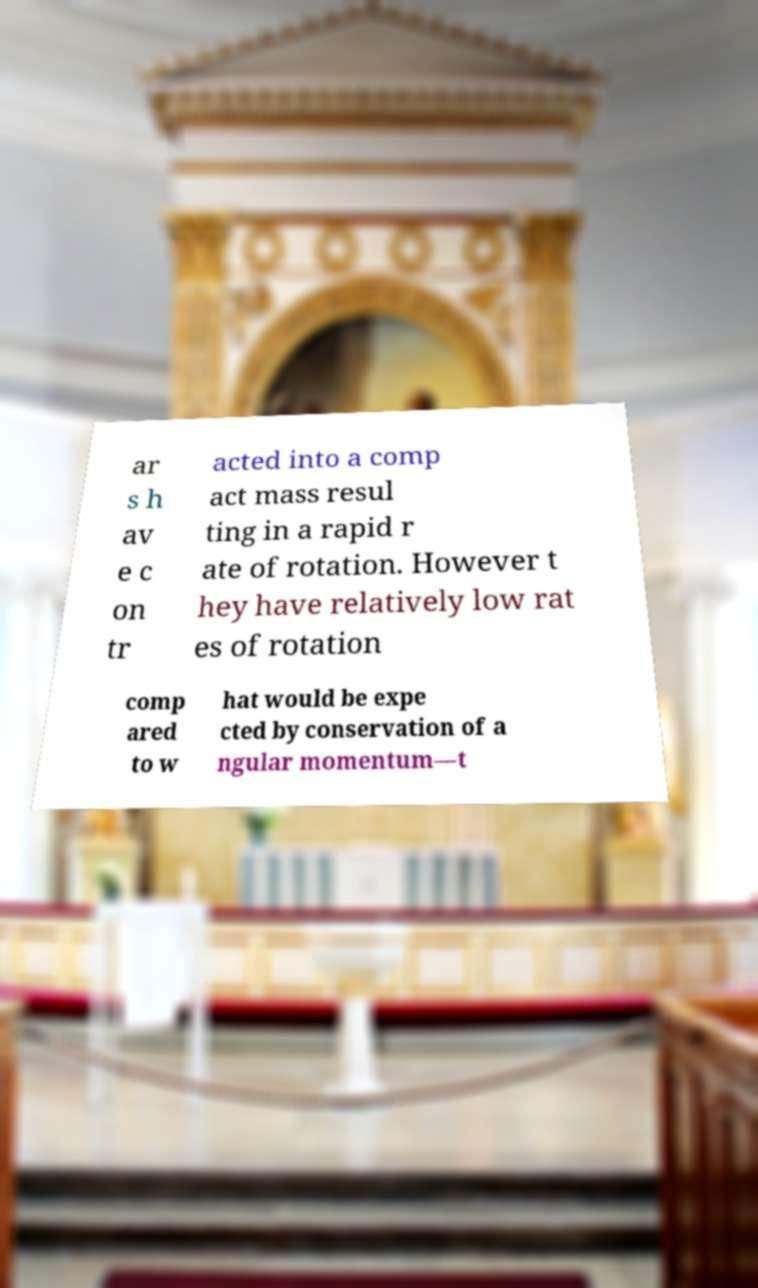Could you extract and type out the text from this image? ar s h av e c on tr acted into a comp act mass resul ting in a rapid r ate of rotation. However t hey have relatively low rat es of rotation comp ared to w hat would be expe cted by conservation of a ngular momentum—t 